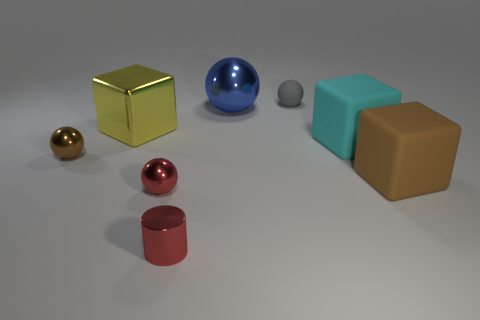Subtract all blue spheres. How many spheres are left? 3 Subtract 1 blocks. How many blocks are left? 2 Subtract all brown balls. How many balls are left? 3 Subtract all yellow spheres. Subtract all green cubes. How many spheres are left? 4 Add 2 small shiny spheres. How many objects exist? 10 Subtract all cylinders. How many objects are left? 7 Add 6 big brown metal things. How many big brown metal things exist? 6 Subtract 0 cyan cylinders. How many objects are left? 8 Subtract all shiny cubes. Subtract all rubber cubes. How many objects are left? 5 Add 4 brown metal objects. How many brown metal objects are left? 5 